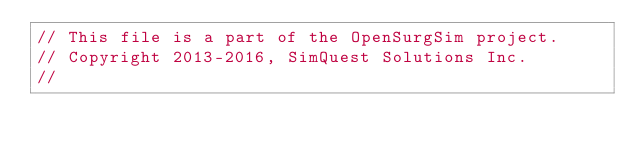<code> <loc_0><loc_0><loc_500><loc_500><_C++_>// This file is a part of the OpenSurgSim project.
// Copyright 2013-2016, SimQuest Solutions Inc.
//</code> 